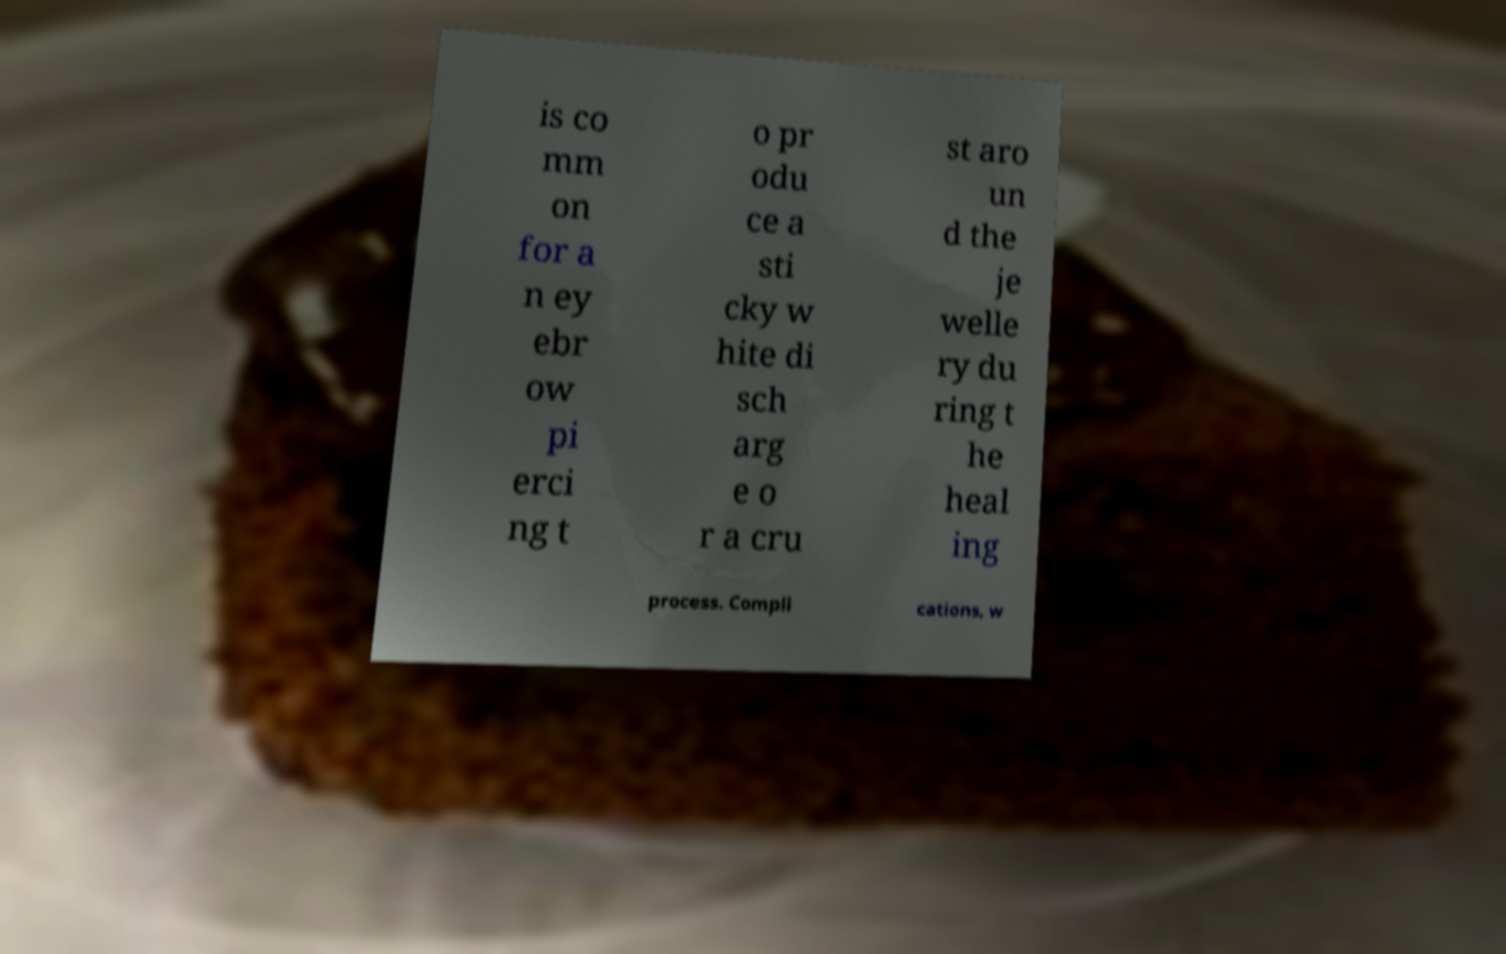Could you extract and type out the text from this image? is co mm on for a n ey ebr ow pi erci ng t o pr odu ce a sti cky w hite di sch arg e o r a cru st aro un d the je welle ry du ring t he heal ing process. Compli cations, w 